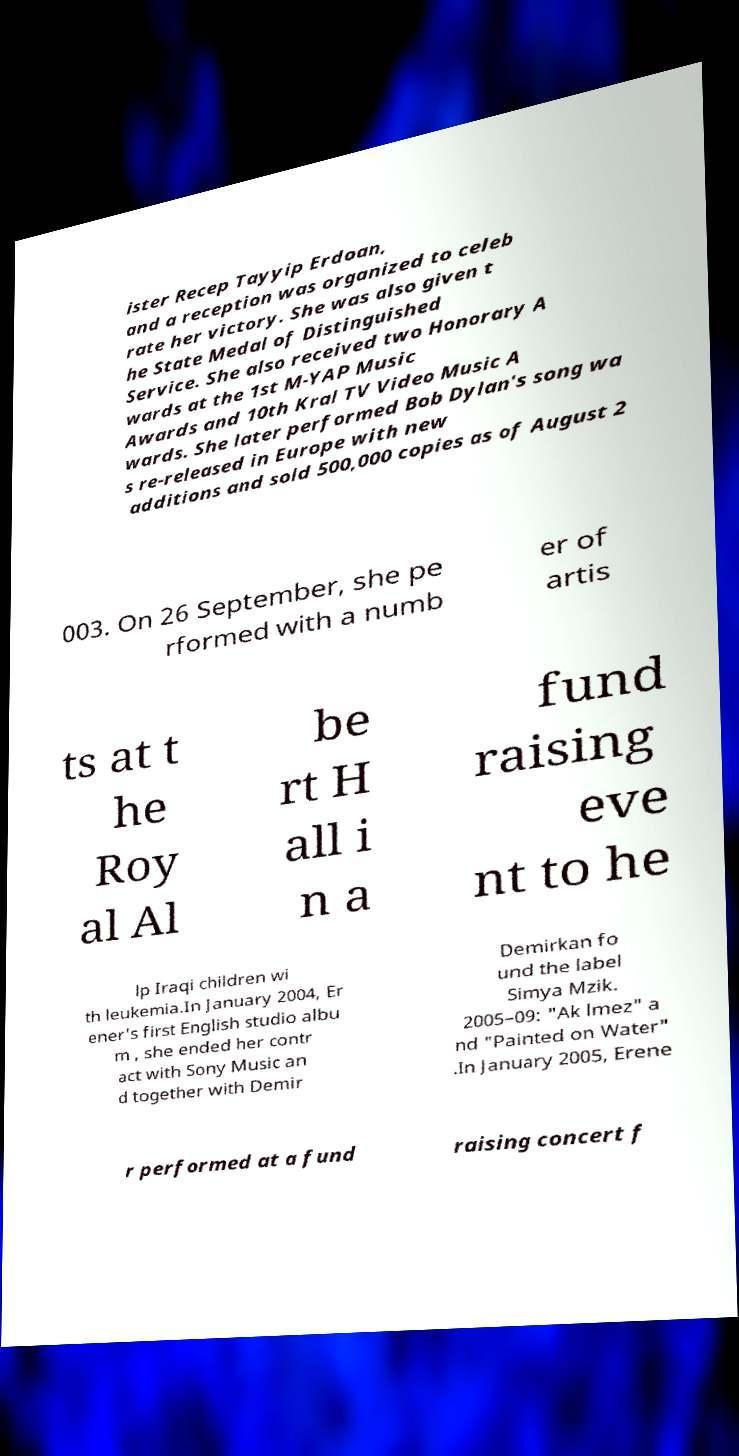Can you read and provide the text displayed in the image?This photo seems to have some interesting text. Can you extract and type it out for me? ister Recep Tayyip Erdoan, and a reception was organized to celeb rate her victory. She was also given t he State Medal of Distinguished Service. She also received two Honorary A wards at the 1st M-YAP Music Awards and 10th Kral TV Video Music A wards. She later performed Bob Dylan's song wa s re-released in Europe with new additions and sold 500,000 copies as of August 2 003. On 26 September, she pe rformed with a numb er of artis ts at t he Roy al Al be rt H all i n a fund raising eve nt to he lp Iraqi children wi th leukemia.In January 2004, Er ener's first English studio albu m , she ended her contr act with Sony Music an d together with Demir Demirkan fo und the label Simya Mzik. 2005–09: "Ak lmez" a nd "Painted on Water" .In January 2005, Erene r performed at a fund raising concert f 